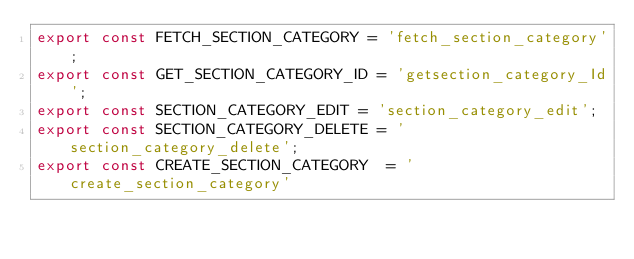Convert code to text. <code><loc_0><loc_0><loc_500><loc_500><_JavaScript_>export const FETCH_SECTION_CATEGORY = 'fetch_section_category';
export const GET_SECTION_CATEGORY_ID = 'getsection_category_Id';
export const SECTION_CATEGORY_EDIT = 'section_category_edit';
export const SECTION_CATEGORY_DELETE = 'section_category_delete';
export const CREATE_SECTION_CATEGORY  = 'create_section_category'</code> 